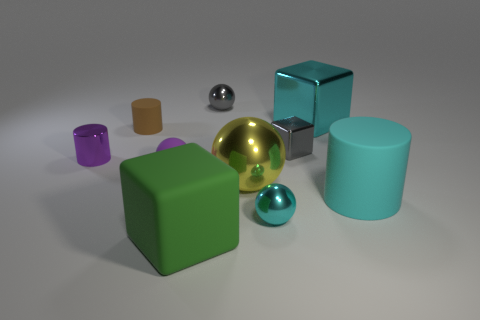What could be the purpose of arranging these objects with different colors and sizes? The arrangement of objects with varying colors and sizes could be an art installation designed to explore visual contrast or a demonstration of 3D rendering techniques showcasing reflection and texture properties in different lighting scenarios. 